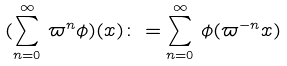Convert formula to latex. <formula><loc_0><loc_0><loc_500><loc_500>( \sum _ { n = 0 } ^ { \infty } \, \varpi ^ { n } \phi ) ( x ) \colon = \sum _ { n = 0 } ^ { \infty } \, \phi ( \varpi ^ { - n } x )</formula> 